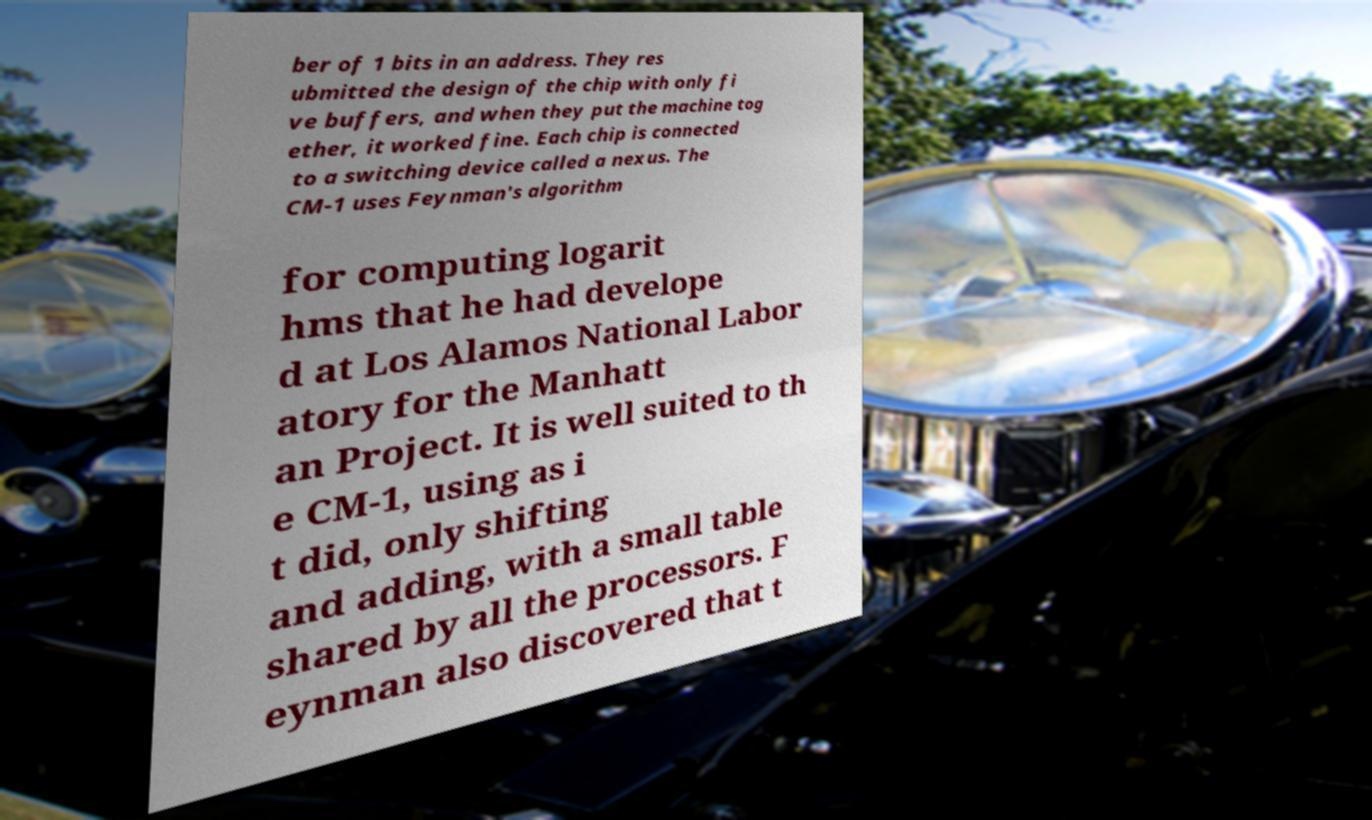I need the written content from this picture converted into text. Can you do that? ber of 1 bits in an address. They res ubmitted the design of the chip with only fi ve buffers, and when they put the machine tog ether, it worked fine. Each chip is connected to a switching device called a nexus. The CM-1 uses Feynman's algorithm for computing logarit hms that he had develope d at Los Alamos National Labor atory for the Manhatt an Project. It is well suited to th e CM-1, using as i t did, only shifting and adding, with a small table shared by all the processors. F eynman also discovered that t 